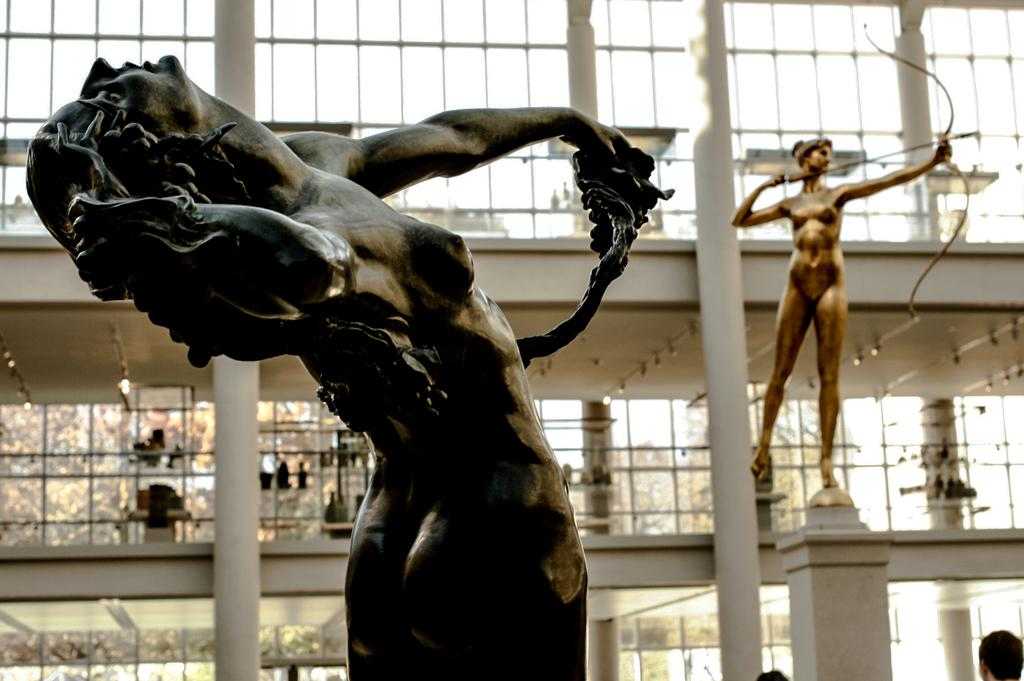What type of art is present in the image? There are sculptures in the image. What can be seen in the background of the image? There are floors and glass walls in the background of the image. How would you describe the overall clarity of the image? The image is blurred. What type of mask is the porter wearing in the image? There is no mask or porter present in the image; it features sculptures and background elements. 